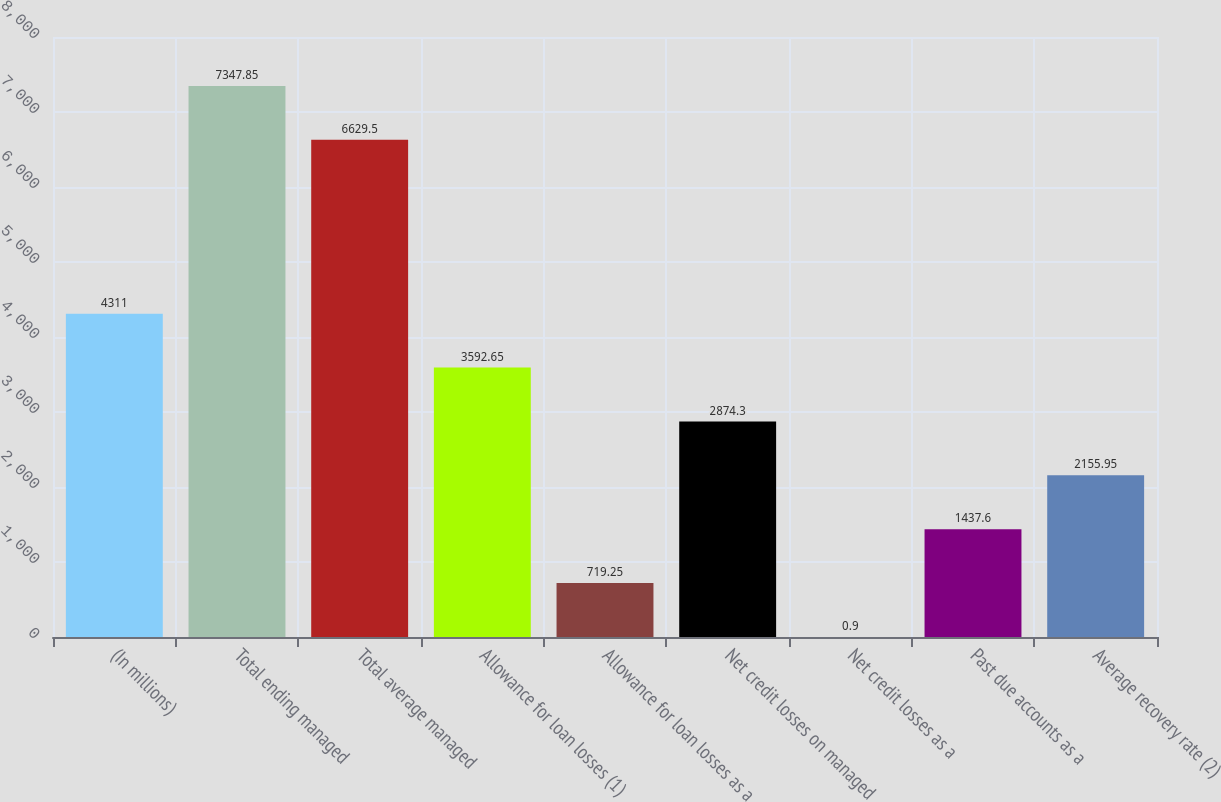<chart> <loc_0><loc_0><loc_500><loc_500><bar_chart><fcel>(In millions)<fcel>Total ending managed<fcel>Total average managed<fcel>Allowance for loan losses (1)<fcel>Allowance for loan losses as a<fcel>Net credit losses on managed<fcel>Net credit losses as a<fcel>Past due accounts as a<fcel>Average recovery rate (2)<nl><fcel>4311<fcel>7347.85<fcel>6629.5<fcel>3592.65<fcel>719.25<fcel>2874.3<fcel>0.9<fcel>1437.6<fcel>2155.95<nl></chart> 